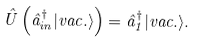Convert formula to latex. <formula><loc_0><loc_0><loc_500><loc_500>\hat { U } \left ( \hat { a } ^ { \dag } _ { i n } | v a c . \rangle \right ) = \hat { a } _ { 1 } ^ { \dag } | v a c . \rangle .</formula> 